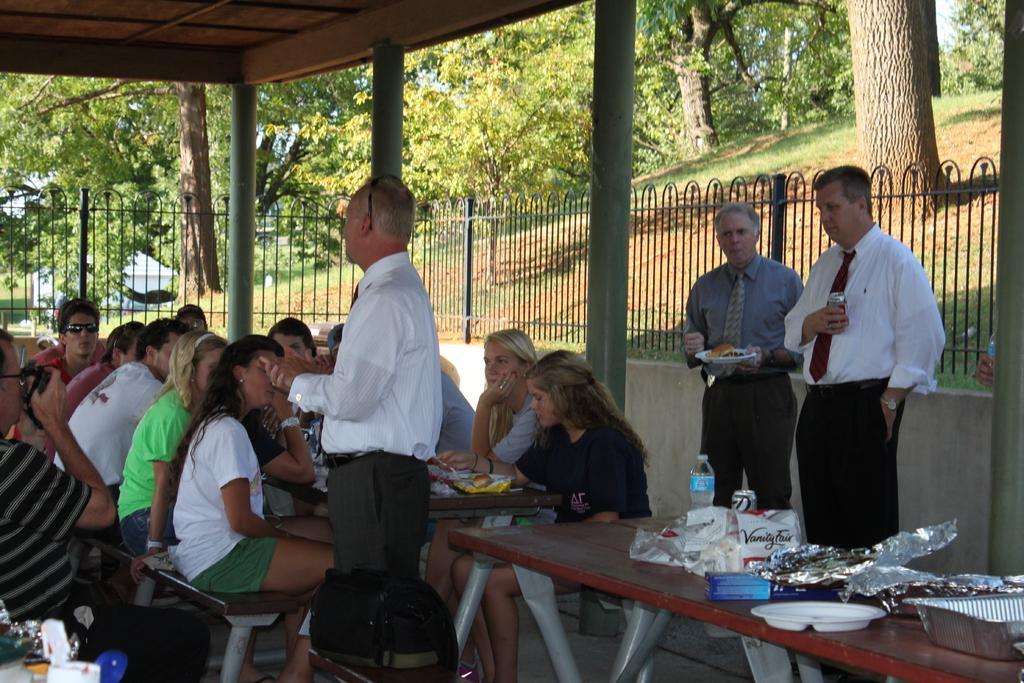Can you describe this image briefly? Here we can see some persons are sitting on the benches. This is table. On the table there is a bottle, covers, and plates. Here we can see three persons are standing on the floor. This is fence and there are trees. And this is grass. 